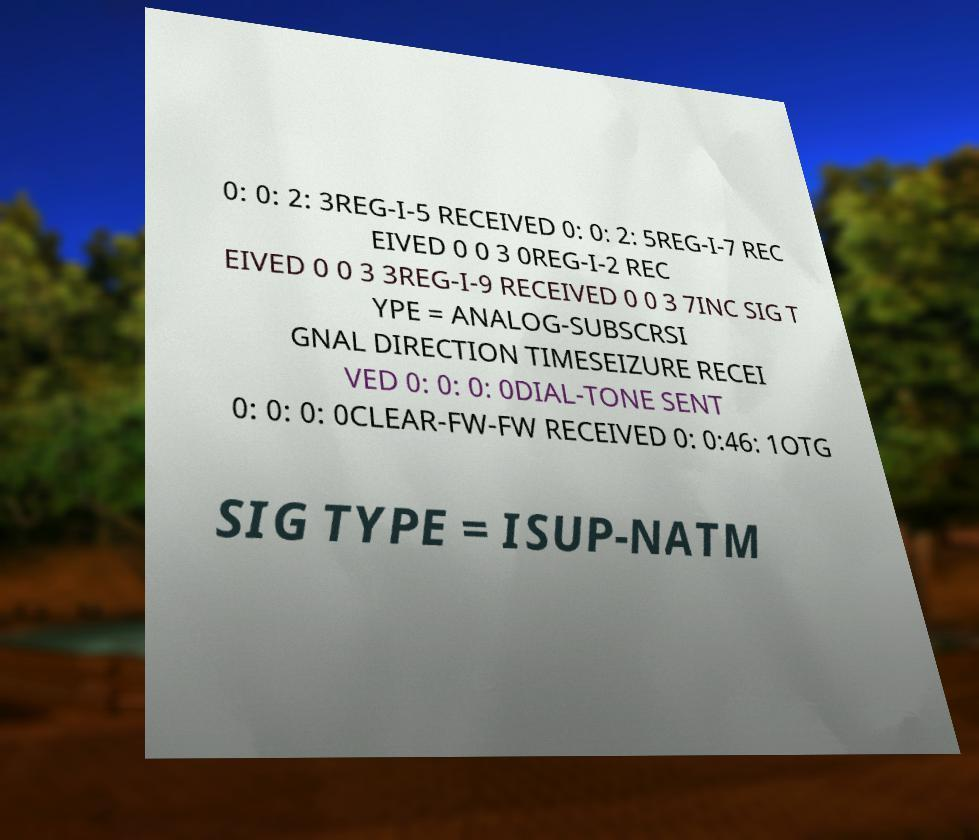Please read and relay the text visible in this image. What does it say? 0: 0: 2: 3REG-I-5 RECEIVED 0: 0: 2: 5REG-I-7 REC EIVED 0 0 3 0REG-I-2 REC EIVED 0 0 3 3REG-I-9 RECEIVED 0 0 3 7INC SIG T YPE = ANALOG-SUBSCRSI GNAL DIRECTION TIMESEIZURE RECEI VED 0: 0: 0: 0DIAL-TONE SENT 0: 0: 0: 0CLEAR-FW-FW RECEIVED 0: 0:46: 1OTG SIG TYPE = ISUP-NATM 